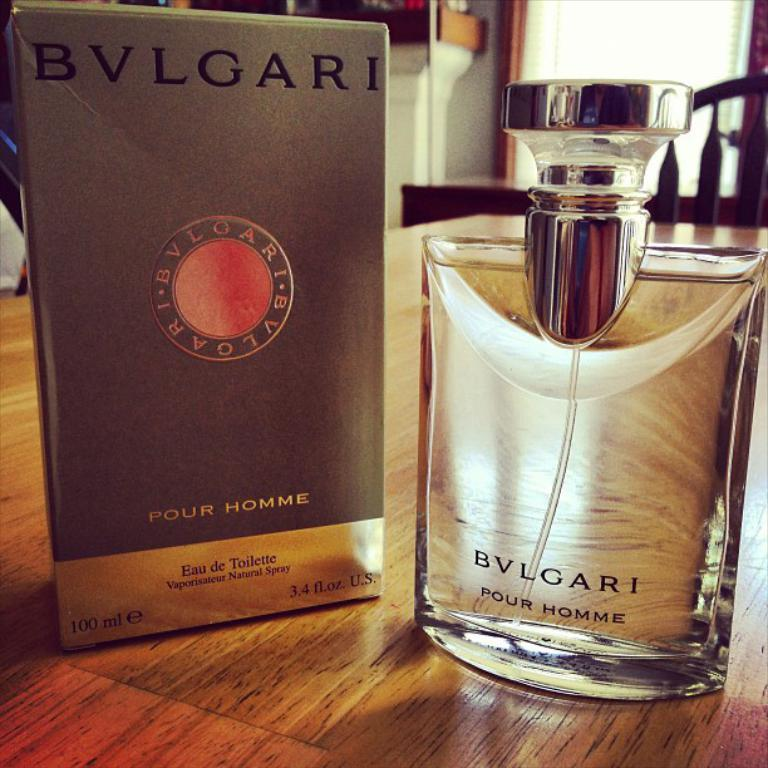<image>
Present a compact description of the photo's key features. A spray bottle of and a box for Bulgari Pour Homme Eau de Toilette. 